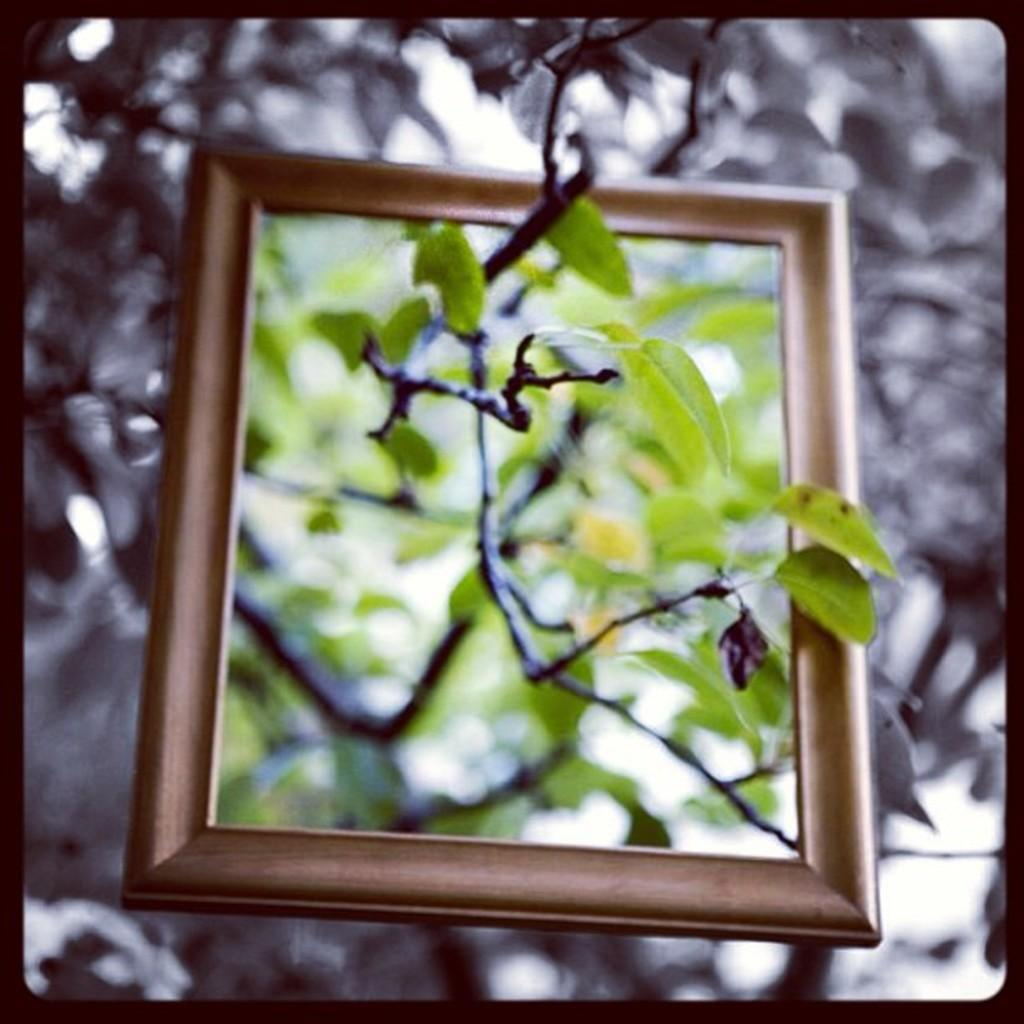What is the main subject of the image? There is a frame in the image. What can be seen inside the frame? A branch of a tree is visible in the image. How would you describe the background of the image? The background of the image is blurred. What type of form does the yak take in the image? There is no yak present in the image. Can you tell me which actor is featured in the image? The image does not feature any actors; it contains a frame with a branch of a tree inside. 